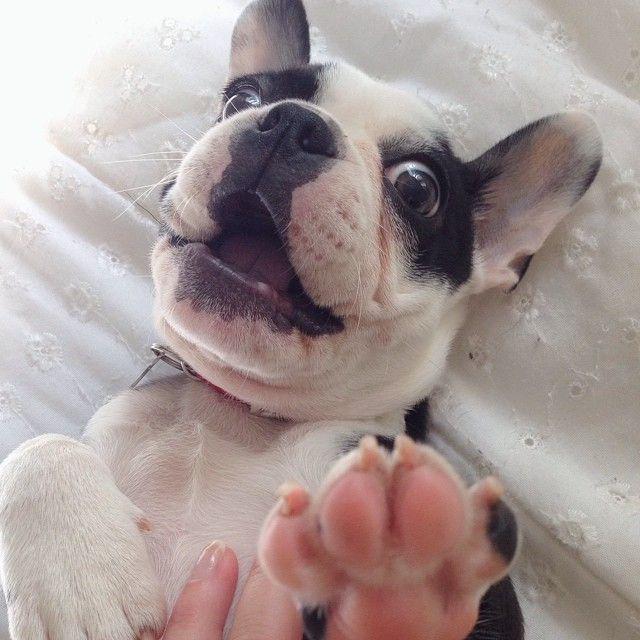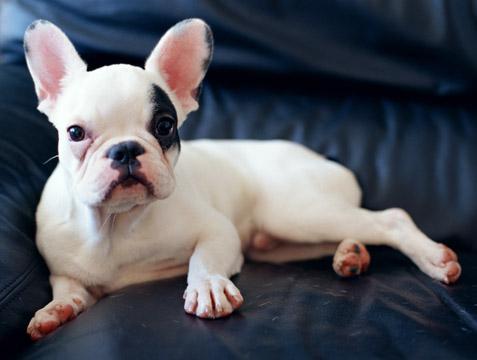The first image is the image on the left, the second image is the image on the right. Evaluate the accuracy of this statement regarding the images: "The right image contains one dark french bulldog facing forward, the left image contains a white bulldog in the foreground, and one of the dogs pictured has its tongue out.". Is it true? Answer yes or no. No. The first image is the image on the left, the second image is the image on the right. Considering the images on both sides, is "One dog is standing." valid? Answer yes or no. No. 